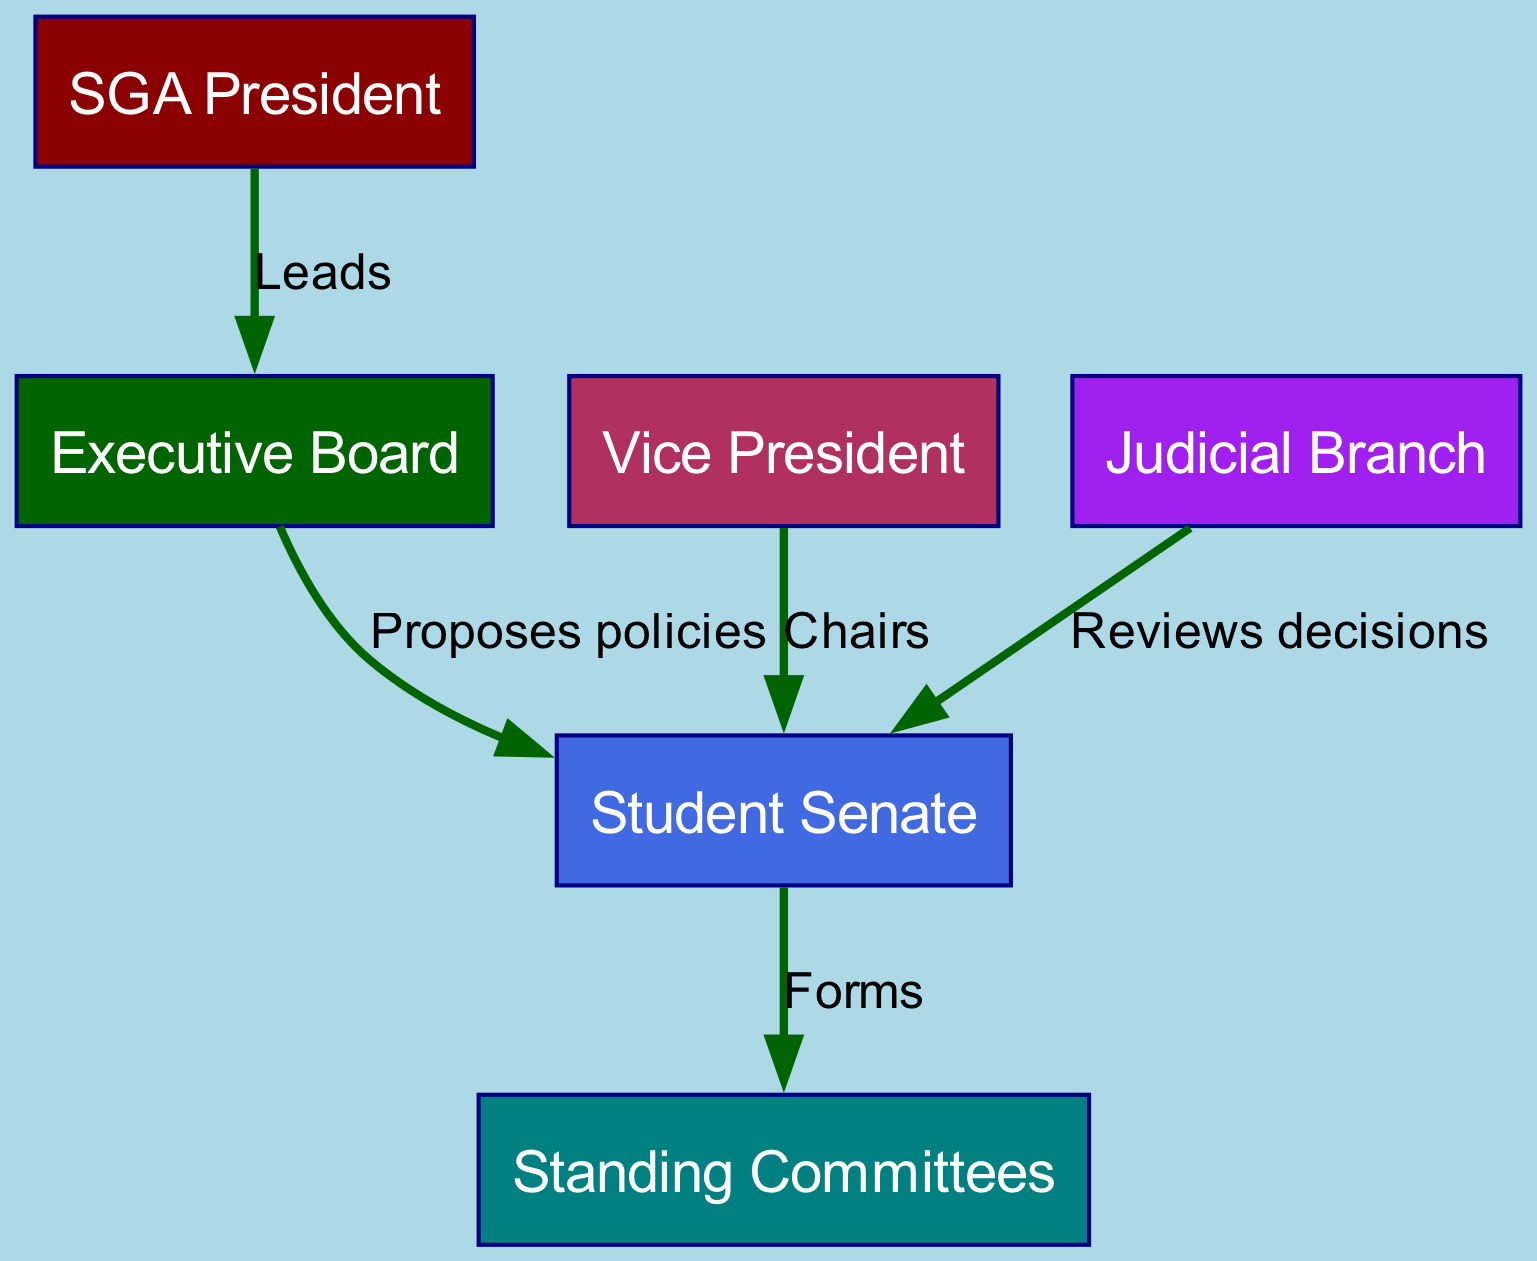What is the title of the highest position in the SGA? The diagram indicates that the highest position is the "SGA President," represented at the top of the structure.
Answer: SGA President How many main branches are represented in the SGA diagram? By analyzing the diagram, we can identify three main branches: Executive Board, Student Senate, and Judicial Branch.
Answer: Three What role does the Vice President play in the organization? The diagram shows that the Vice President "Chairs" the Student Senate, making this their primary function within the structure.
Answer: Chairs Which entity reviews decisions made by the Student Senate? The diagram clearly indicates that the "Judicial Branch" is responsible for reviewing decisions made by the Student Senate.
Answer: Judicial Branch What relationship does the Executive Board have with the Student Senate? According to the diagram, the Executive Board "Proposes policies" to the Student Senate, which establishes their interactive relationship.
Answer: Proposes policies How many committees are formed by the Student Senate? The diagram indicates that the Student Senate "Forms" Standing Committees; however, it does not specify a number for these committees.
Answer: Not specified Who leads the Executive Board? The diagram shows that the "SGA President" leads the Executive Board, creating a direct connection between these two roles.
Answer: SGA President What is the color associated with the Judicial Branch in the diagram? The diagram assigns the color purple to the Judicial Branch, which helps differentiate it from the other elements visually.
Answer: Purple What function does the Executive Board serve in relation to policies? The diagram indicates that the Executive Board's function is to "Propose policies" to the Student Senate, representing their role in decision-making.
Answer: Propose policies 